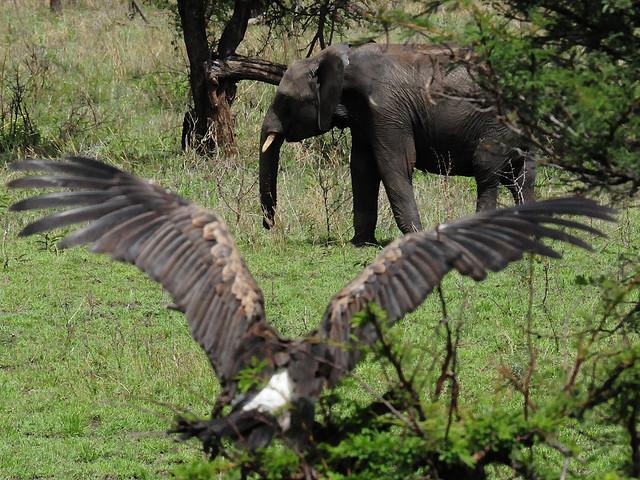Does one of these creatures nest on the ground?
Write a very short answer. Yes. What direction is the elephant going?
Write a very short answer. Left. How many different animals are there in this photo?
Quick response, please. 2. 